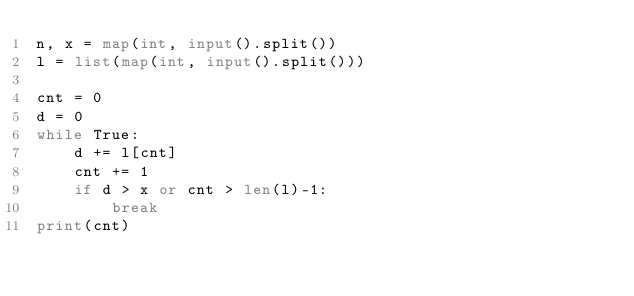Convert code to text. <code><loc_0><loc_0><loc_500><loc_500><_Python_>n, x = map(int, input().split())
l = list(map(int, input().split()))

cnt = 0
d = 0
while True:
    d += l[cnt]
    cnt += 1
    if d > x or cnt > len(l)-1:
        break
print(cnt)
</code> 